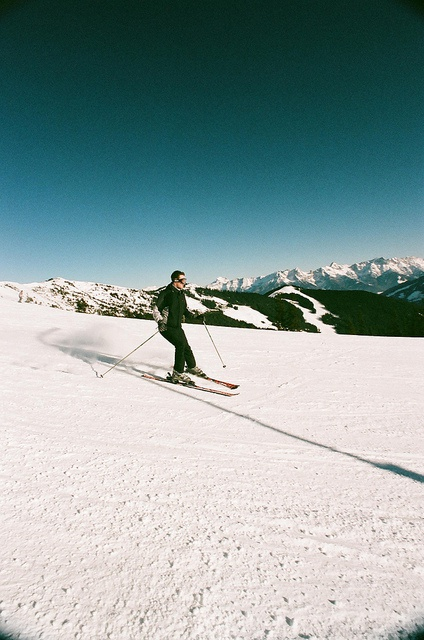Describe the objects in this image and their specific colors. I can see people in black, white, gray, and darkgreen tones, skis in black, white, tan, gray, and darkgray tones, and skis in black, brown, and maroon tones in this image. 